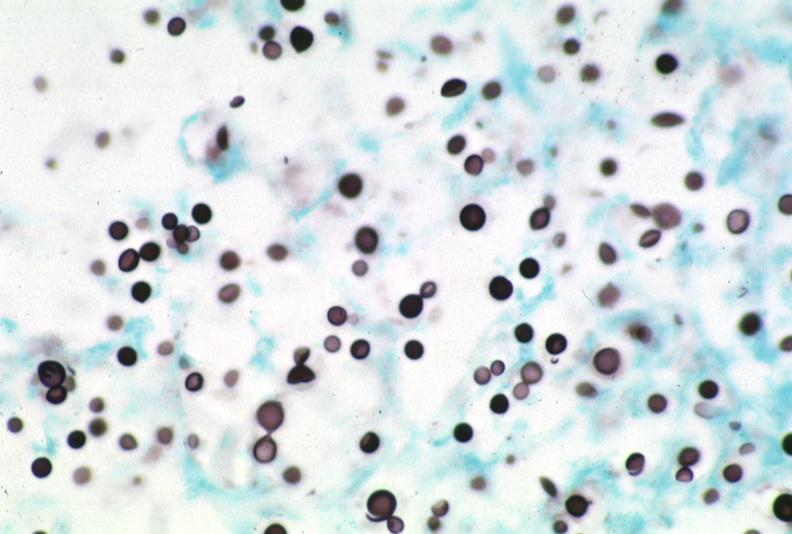does this image show lymph node, cryptococcosis gms?
Answer the question using a single word or phrase. Yes 